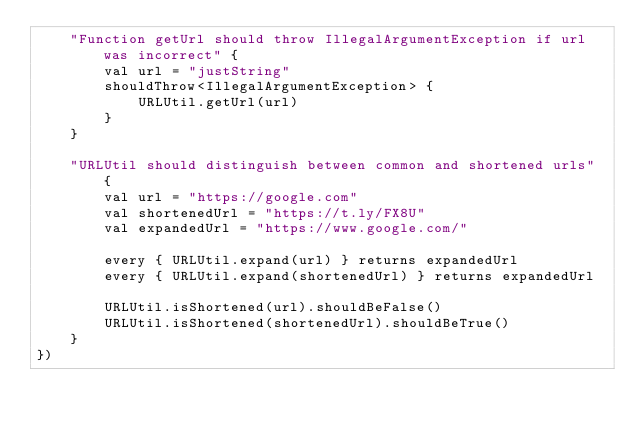Convert code to text. <code><loc_0><loc_0><loc_500><loc_500><_Kotlin_>    "Function getUrl should throw IllegalArgumentException if url was incorrect" {
        val url = "justString"
        shouldThrow<IllegalArgumentException> {
            URLUtil.getUrl(url)
        }
    }

    "URLUtil should distinguish between common and shortened urls" {
        val url = "https://google.com"
        val shortenedUrl = "https://t.ly/FX8U"
        val expandedUrl = "https://www.google.com/"

        every { URLUtil.expand(url) } returns expandedUrl
        every { URLUtil.expand(shortenedUrl) } returns expandedUrl

        URLUtil.isShortened(url).shouldBeFalse()
        URLUtil.isShortened(shortenedUrl).shouldBeTrue()
    }
})
</code> 